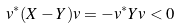Convert formula to latex. <formula><loc_0><loc_0><loc_500><loc_500>v ^ { * } ( X - Y ) v = - v ^ { * } Y v < 0</formula> 